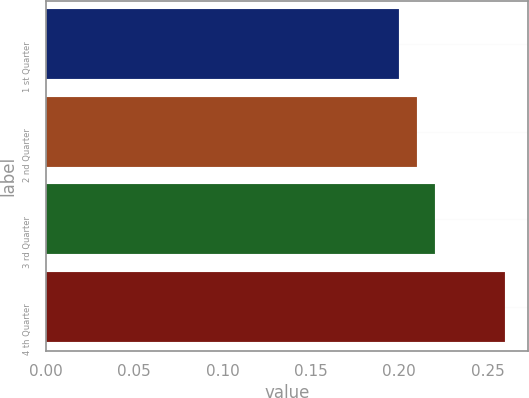Convert chart to OTSL. <chart><loc_0><loc_0><loc_500><loc_500><bar_chart><fcel>1 st Quarter<fcel>2 nd Quarter<fcel>3 rd Quarter<fcel>4 th Quarter<nl><fcel>0.2<fcel>0.21<fcel>0.22<fcel>0.26<nl></chart> 